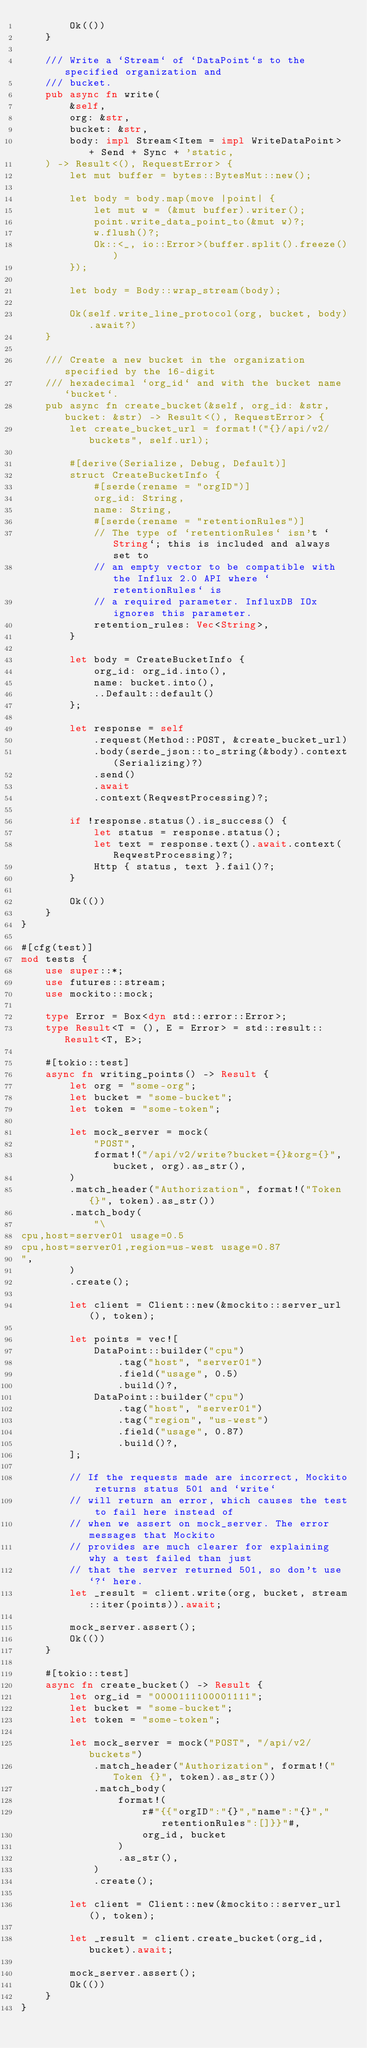Convert code to text. <code><loc_0><loc_0><loc_500><loc_500><_Rust_>        Ok(())
    }

    /// Write a `Stream` of `DataPoint`s to the specified organization and
    /// bucket.
    pub async fn write(
        &self,
        org: &str,
        bucket: &str,
        body: impl Stream<Item = impl WriteDataPoint> + Send + Sync + 'static,
    ) -> Result<(), RequestError> {
        let mut buffer = bytes::BytesMut::new();

        let body = body.map(move |point| {
            let mut w = (&mut buffer).writer();
            point.write_data_point_to(&mut w)?;
            w.flush()?;
            Ok::<_, io::Error>(buffer.split().freeze())
        });

        let body = Body::wrap_stream(body);

        Ok(self.write_line_protocol(org, bucket, body).await?)
    }

    /// Create a new bucket in the organization specified by the 16-digit
    /// hexadecimal `org_id` and with the bucket name `bucket`.
    pub async fn create_bucket(&self, org_id: &str, bucket: &str) -> Result<(), RequestError> {
        let create_bucket_url = format!("{}/api/v2/buckets", self.url);

        #[derive(Serialize, Debug, Default)]
        struct CreateBucketInfo {
            #[serde(rename = "orgID")]
            org_id: String,
            name: String,
            #[serde(rename = "retentionRules")]
            // The type of `retentionRules` isn't `String`; this is included and always set to
            // an empty vector to be compatible with the Influx 2.0 API where `retentionRules` is
            // a required parameter. InfluxDB IOx ignores this parameter.
            retention_rules: Vec<String>,
        }

        let body = CreateBucketInfo {
            org_id: org_id.into(),
            name: bucket.into(),
            ..Default::default()
        };

        let response = self
            .request(Method::POST, &create_bucket_url)
            .body(serde_json::to_string(&body).context(Serializing)?)
            .send()
            .await
            .context(ReqwestProcessing)?;

        if !response.status().is_success() {
            let status = response.status();
            let text = response.text().await.context(ReqwestProcessing)?;
            Http { status, text }.fail()?;
        }

        Ok(())
    }
}

#[cfg(test)]
mod tests {
    use super::*;
    use futures::stream;
    use mockito::mock;

    type Error = Box<dyn std::error::Error>;
    type Result<T = (), E = Error> = std::result::Result<T, E>;

    #[tokio::test]
    async fn writing_points() -> Result {
        let org = "some-org";
        let bucket = "some-bucket";
        let token = "some-token";

        let mock_server = mock(
            "POST",
            format!("/api/v2/write?bucket={}&org={}", bucket, org).as_str(),
        )
        .match_header("Authorization", format!("Token {}", token).as_str())
        .match_body(
            "\
cpu,host=server01 usage=0.5
cpu,host=server01,region=us-west usage=0.87
",
        )
        .create();

        let client = Client::new(&mockito::server_url(), token);

        let points = vec![
            DataPoint::builder("cpu")
                .tag("host", "server01")
                .field("usage", 0.5)
                .build()?,
            DataPoint::builder("cpu")
                .tag("host", "server01")
                .tag("region", "us-west")
                .field("usage", 0.87)
                .build()?,
        ];

        // If the requests made are incorrect, Mockito returns status 501 and `write`
        // will return an error, which causes the test to fail here instead of
        // when we assert on mock_server. The error messages that Mockito
        // provides are much clearer for explaining why a test failed than just
        // that the server returned 501, so don't use `?` here.
        let _result = client.write(org, bucket, stream::iter(points)).await;

        mock_server.assert();
        Ok(())
    }

    #[tokio::test]
    async fn create_bucket() -> Result {
        let org_id = "0000111100001111";
        let bucket = "some-bucket";
        let token = "some-token";

        let mock_server = mock("POST", "/api/v2/buckets")
            .match_header("Authorization", format!("Token {}", token).as_str())
            .match_body(
                format!(
                    r#"{{"orgID":"{}","name":"{}","retentionRules":[]}}"#,
                    org_id, bucket
                )
                .as_str(),
            )
            .create();

        let client = Client::new(&mockito::server_url(), token);

        let _result = client.create_bucket(org_id, bucket).await;

        mock_server.assert();
        Ok(())
    }
}
</code> 